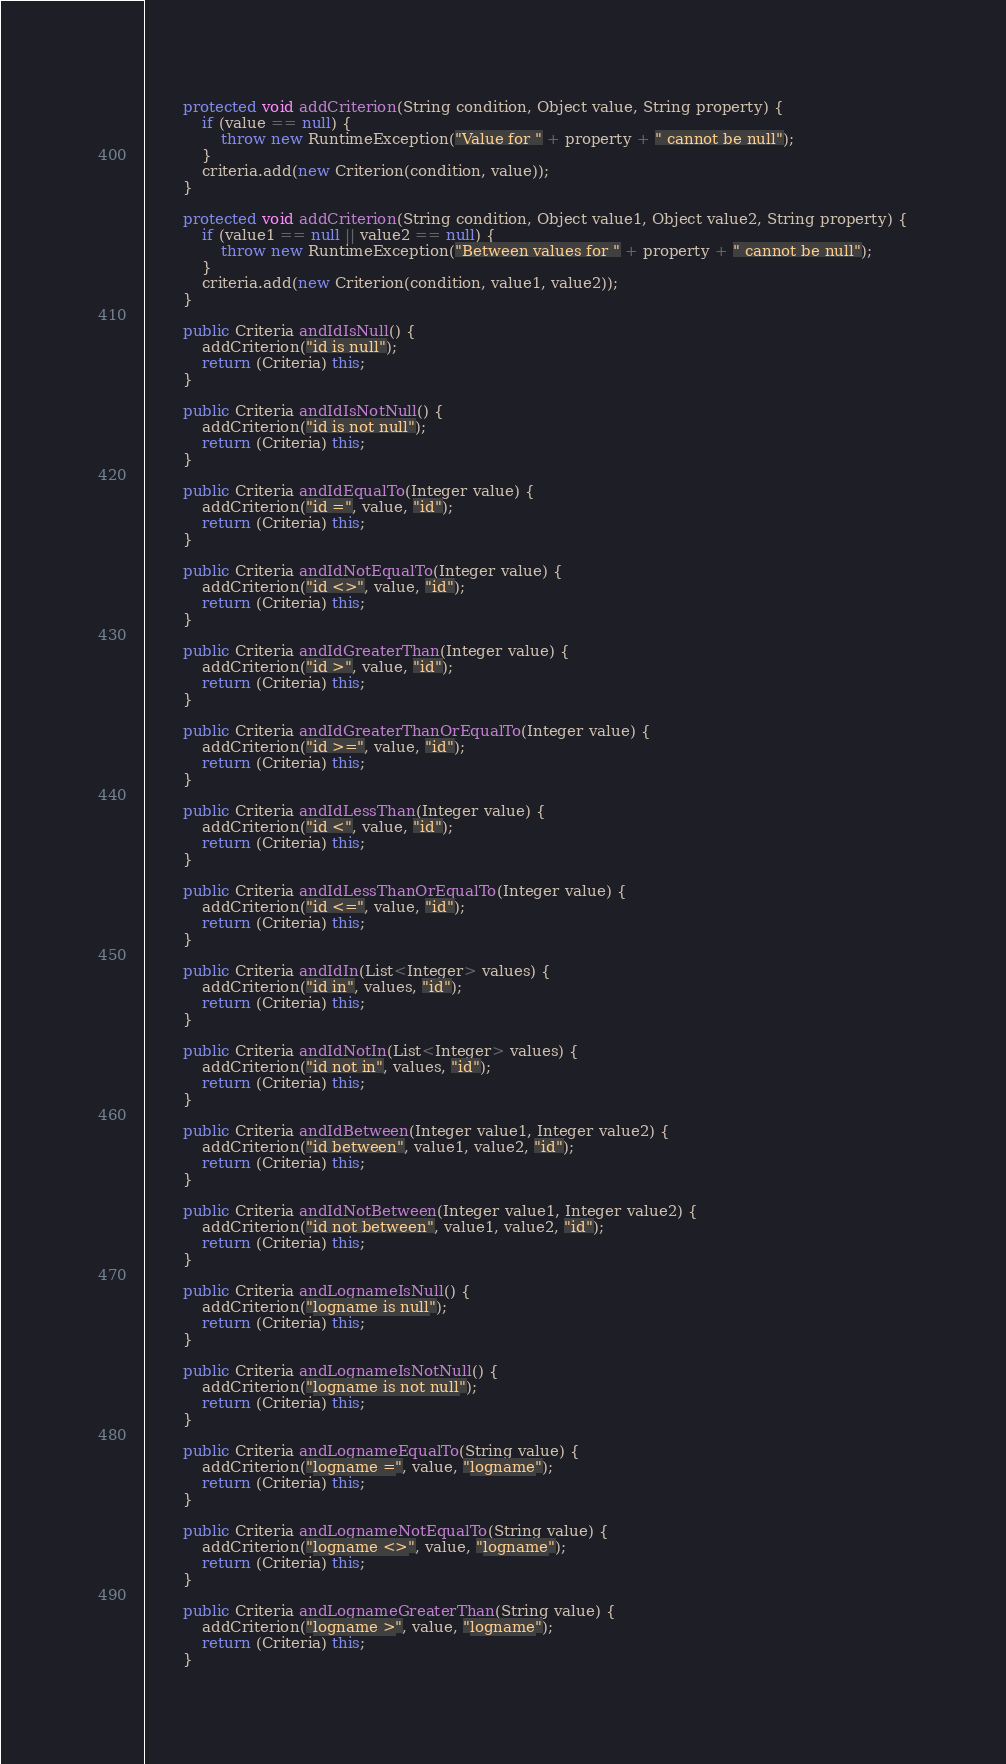<code> <loc_0><loc_0><loc_500><loc_500><_Java_>        protected void addCriterion(String condition, Object value, String property) {
            if (value == null) {
                throw new RuntimeException("Value for " + property + " cannot be null");
            }
            criteria.add(new Criterion(condition, value));
        }

        protected void addCriterion(String condition, Object value1, Object value2, String property) {
            if (value1 == null || value2 == null) {
                throw new RuntimeException("Between values for " + property + " cannot be null");
            }
            criteria.add(new Criterion(condition, value1, value2));
        }

        public Criteria andIdIsNull() {
            addCriterion("id is null");
            return (Criteria) this;
        }

        public Criteria andIdIsNotNull() {
            addCriterion("id is not null");
            return (Criteria) this;
        }

        public Criteria andIdEqualTo(Integer value) {
            addCriterion("id =", value, "id");
            return (Criteria) this;
        }

        public Criteria andIdNotEqualTo(Integer value) {
            addCriterion("id <>", value, "id");
            return (Criteria) this;
        }

        public Criteria andIdGreaterThan(Integer value) {
            addCriterion("id >", value, "id");
            return (Criteria) this;
        }

        public Criteria andIdGreaterThanOrEqualTo(Integer value) {
            addCriterion("id >=", value, "id");
            return (Criteria) this;
        }

        public Criteria andIdLessThan(Integer value) {
            addCriterion("id <", value, "id");
            return (Criteria) this;
        }

        public Criteria andIdLessThanOrEqualTo(Integer value) {
            addCriterion("id <=", value, "id");
            return (Criteria) this;
        }

        public Criteria andIdIn(List<Integer> values) {
            addCriterion("id in", values, "id");
            return (Criteria) this;
        }

        public Criteria andIdNotIn(List<Integer> values) {
            addCriterion("id not in", values, "id");
            return (Criteria) this;
        }

        public Criteria andIdBetween(Integer value1, Integer value2) {
            addCriterion("id between", value1, value2, "id");
            return (Criteria) this;
        }

        public Criteria andIdNotBetween(Integer value1, Integer value2) {
            addCriterion("id not between", value1, value2, "id");
            return (Criteria) this;
        }

        public Criteria andLognameIsNull() {
            addCriterion("logname is null");
            return (Criteria) this;
        }

        public Criteria andLognameIsNotNull() {
            addCriterion("logname is not null");
            return (Criteria) this;
        }

        public Criteria andLognameEqualTo(String value) {
            addCriterion("logname =", value, "logname");
            return (Criteria) this;
        }

        public Criteria andLognameNotEqualTo(String value) {
            addCriterion("logname <>", value, "logname");
            return (Criteria) this;
        }

        public Criteria andLognameGreaterThan(String value) {
            addCriterion("logname >", value, "logname");
            return (Criteria) this;
        }
</code> 